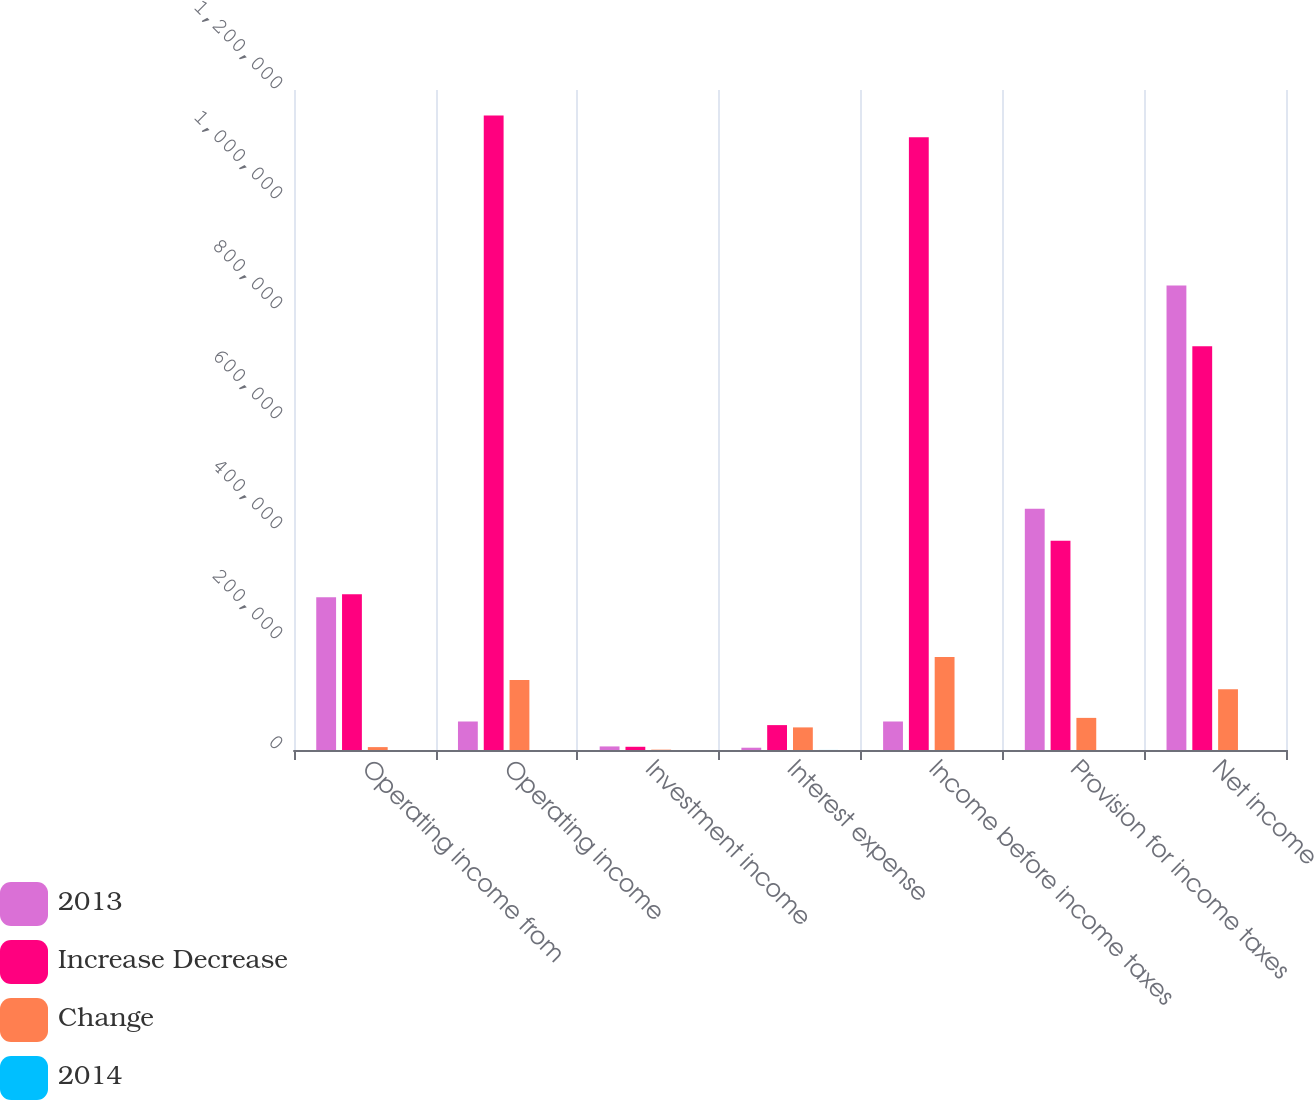<chart> <loc_0><loc_0><loc_500><loc_500><stacked_bar_chart><ecel><fcel>Operating income from<fcel>Operating income<fcel>Investment income<fcel>Interest expense<fcel>Income before income taxes<fcel>Provision for income taxes<fcel>Net income<nl><fcel>2013<fcel>277836<fcel>51826.5<fcel>6499<fcel>4162<fcel>51826.5<fcel>438709<fcel>844611<nl><fcel>Increase Decrease<fcel>283093<fcel>1.1537e+06<fcel>5859<fcel>45256<fcel>1.1143e+06<fcel>380312<fcel>733993<nl><fcel>Change<fcel>5257<fcel>127281<fcel>640<fcel>41094<fcel>169015<fcel>58397<fcel>110618<nl><fcel>2014<fcel>1.9<fcel>11<fcel>10.9<fcel>90.8<fcel>15.2<fcel>15.4<fcel>15.1<nl></chart> 